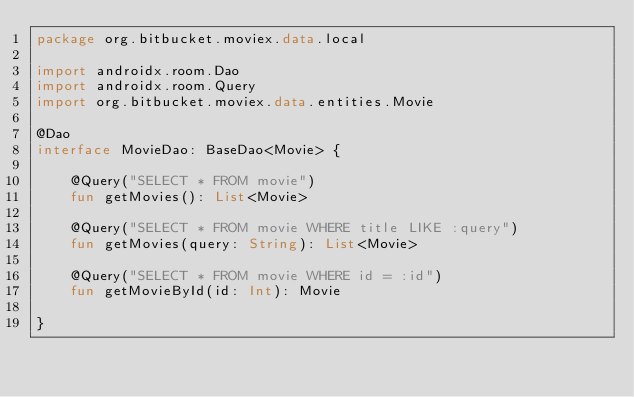<code> <loc_0><loc_0><loc_500><loc_500><_Kotlin_>package org.bitbucket.moviex.data.local

import androidx.room.Dao
import androidx.room.Query
import org.bitbucket.moviex.data.entities.Movie

@Dao
interface MovieDao: BaseDao<Movie> {

    @Query("SELECT * FROM movie")
    fun getMovies(): List<Movie>

    @Query("SELECT * FROM movie WHERE title LIKE :query")
    fun getMovies(query: String): List<Movie>

    @Query("SELECT * FROM movie WHERE id = :id")
    fun getMovieById(id: Int): Movie

}</code> 